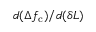Convert formula to latex. <formula><loc_0><loc_0><loc_500><loc_500>d ( \Delta f _ { c } ) / d ( \delta L )</formula> 